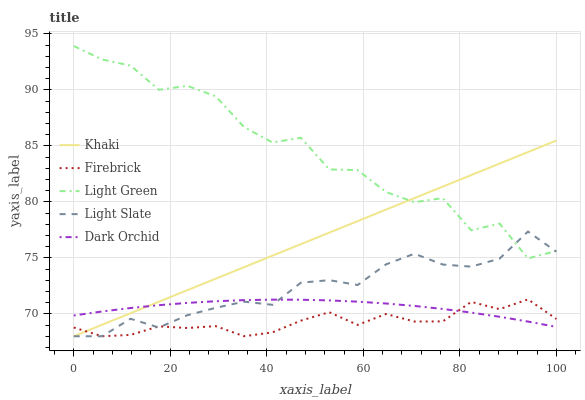Does Khaki have the minimum area under the curve?
Answer yes or no. No. Does Khaki have the maximum area under the curve?
Answer yes or no. No. Is Firebrick the smoothest?
Answer yes or no. No. Is Firebrick the roughest?
Answer yes or no. No. Does Dark Orchid have the lowest value?
Answer yes or no. No. Does Firebrick have the highest value?
Answer yes or no. No. Is Firebrick less than Light Green?
Answer yes or no. Yes. Is Light Green greater than Dark Orchid?
Answer yes or no. Yes. Does Firebrick intersect Light Green?
Answer yes or no. No. 